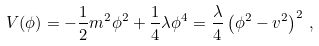Convert formula to latex. <formula><loc_0><loc_0><loc_500><loc_500>V ( \phi ) = - \frac { 1 } { 2 } m ^ { 2 } \phi ^ { 2 } + \frac { 1 } { 4 } \lambda \phi ^ { 4 } = \frac { \lambda } { 4 } \left ( \phi ^ { 2 } - v ^ { 2 } \right ) ^ { 2 } \, ,</formula> 